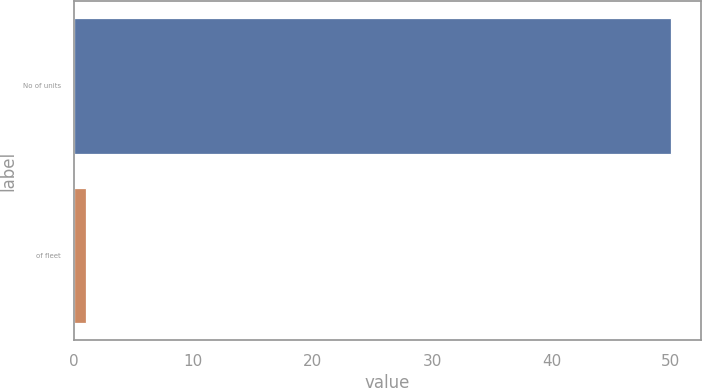Convert chart. <chart><loc_0><loc_0><loc_500><loc_500><bar_chart><fcel>No of units<fcel>of fleet<nl><fcel>50<fcel>1<nl></chart> 